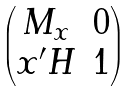Convert formula to latex. <formula><loc_0><loc_0><loc_500><loc_500>\begin{pmatrix} M _ { x } & 0 \\ x ^ { \prime } H & 1 \end{pmatrix}</formula> 